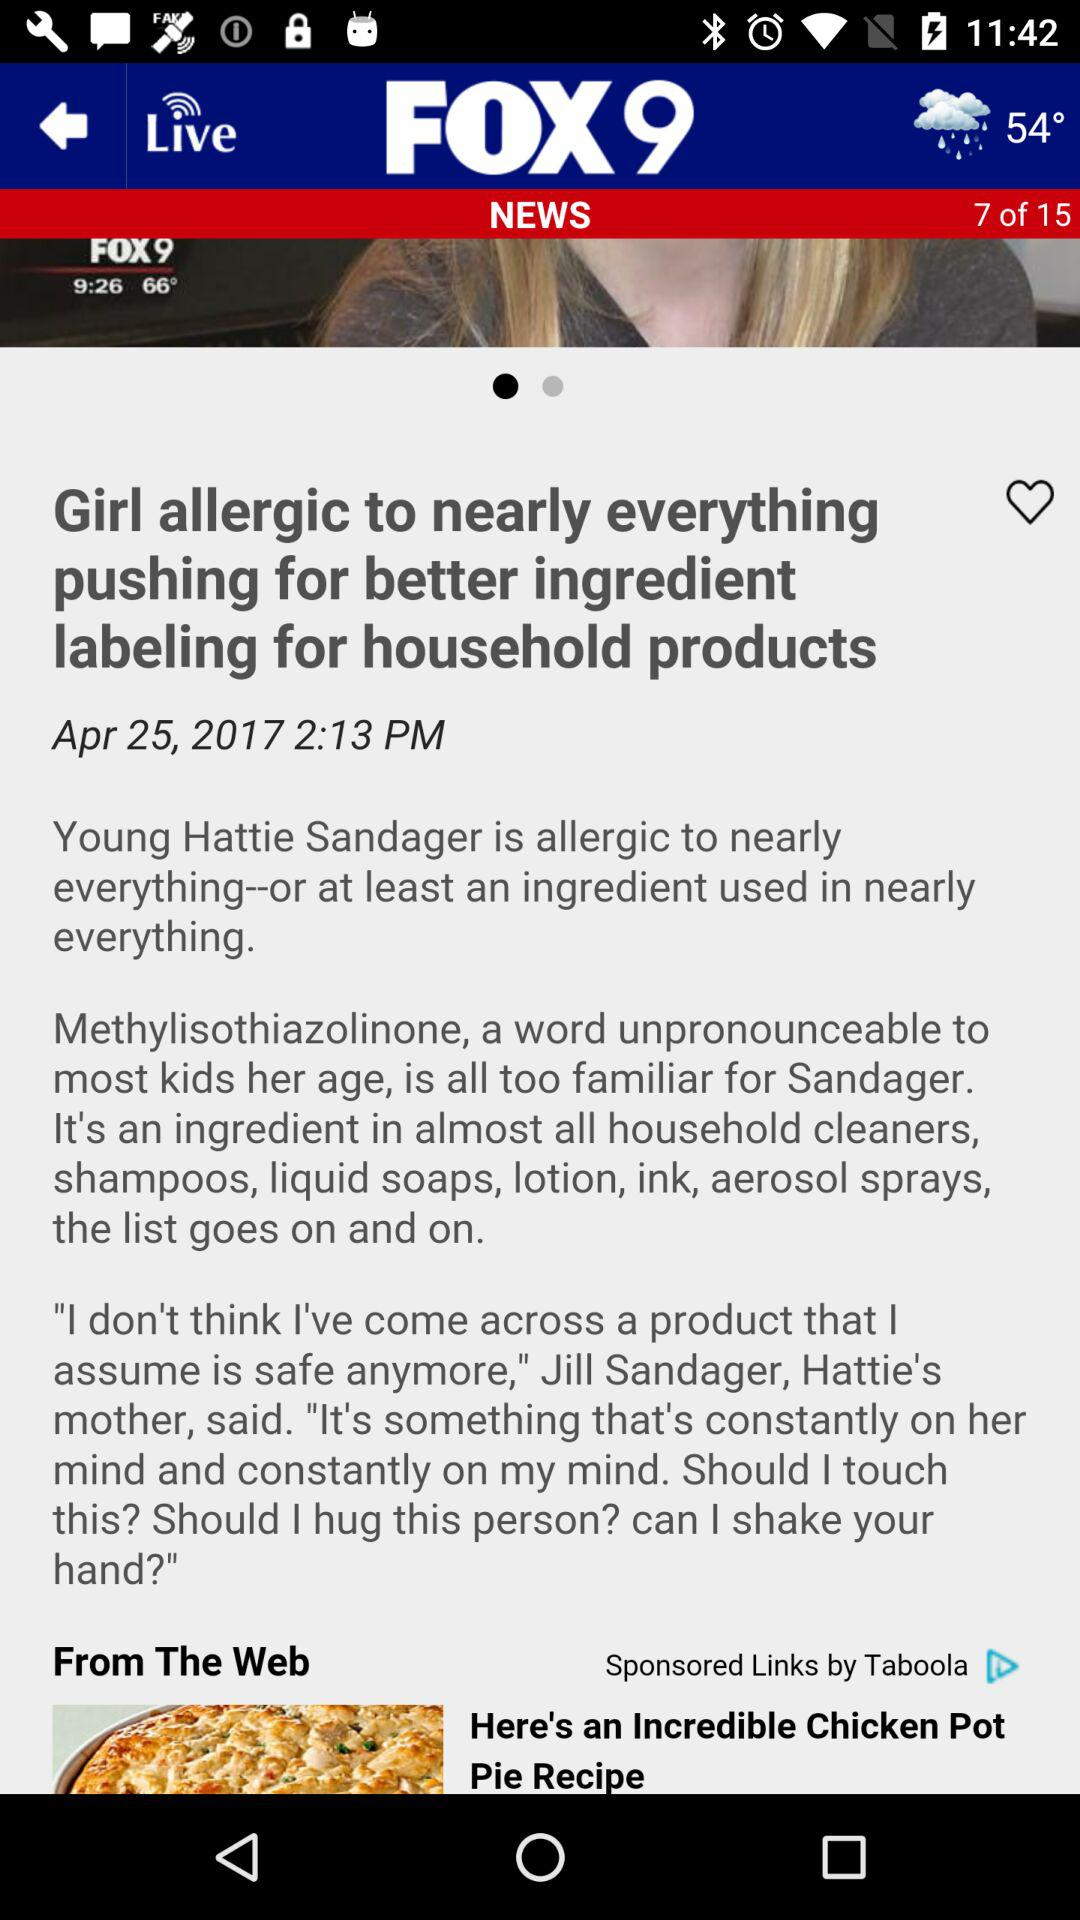What is the type of weather showing in the application? The weather type is rainy. 